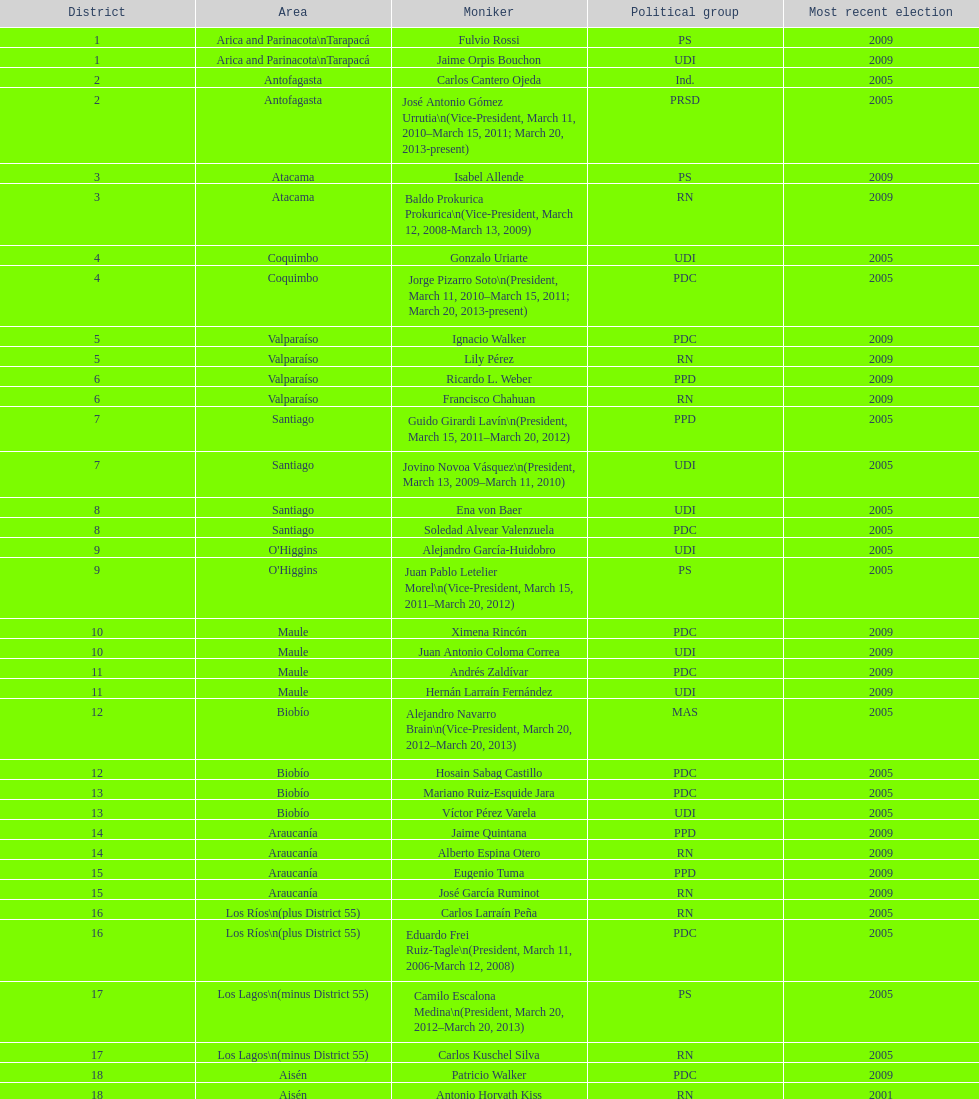How many total consituency are listed in the table? 19. Give me the full table as a dictionary. {'header': ['District', 'Area', 'Moniker', 'Political group', 'Most recent election'], 'rows': [['1', 'Arica and Parinacota\\nTarapacá', 'Fulvio Rossi', 'PS', '2009'], ['1', 'Arica and Parinacota\\nTarapacá', 'Jaime Orpis Bouchon', 'UDI', '2009'], ['2', 'Antofagasta', 'Carlos Cantero Ojeda', 'Ind.', '2005'], ['2', 'Antofagasta', 'José Antonio Gómez Urrutia\\n(Vice-President, March 11, 2010–March 15, 2011; March 20, 2013-present)', 'PRSD', '2005'], ['3', 'Atacama', 'Isabel Allende', 'PS', '2009'], ['3', 'Atacama', 'Baldo Prokurica Prokurica\\n(Vice-President, March 12, 2008-March 13, 2009)', 'RN', '2009'], ['4', 'Coquimbo', 'Gonzalo Uriarte', 'UDI', '2005'], ['4', 'Coquimbo', 'Jorge Pizarro Soto\\n(President, March 11, 2010–March 15, 2011; March 20, 2013-present)', 'PDC', '2005'], ['5', 'Valparaíso', 'Ignacio Walker', 'PDC', '2009'], ['5', 'Valparaíso', 'Lily Pérez', 'RN', '2009'], ['6', 'Valparaíso', 'Ricardo L. Weber', 'PPD', '2009'], ['6', 'Valparaíso', 'Francisco Chahuan', 'RN', '2009'], ['7', 'Santiago', 'Guido Girardi Lavín\\n(President, March 15, 2011–March 20, 2012)', 'PPD', '2005'], ['7', 'Santiago', 'Jovino Novoa Vásquez\\n(President, March 13, 2009–March 11, 2010)', 'UDI', '2005'], ['8', 'Santiago', 'Ena von Baer', 'UDI', '2005'], ['8', 'Santiago', 'Soledad Alvear Valenzuela', 'PDC', '2005'], ['9', "O'Higgins", 'Alejandro García-Huidobro', 'UDI', '2005'], ['9', "O'Higgins", 'Juan Pablo Letelier Morel\\n(Vice-President, March 15, 2011–March 20, 2012)', 'PS', '2005'], ['10', 'Maule', 'Ximena Rincón', 'PDC', '2009'], ['10', 'Maule', 'Juan Antonio Coloma Correa', 'UDI', '2009'], ['11', 'Maule', 'Andrés Zaldívar', 'PDC', '2009'], ['11', 'Maule', 'Hernán Larraín Fernández', 'UDI', '2009'], ['12', 'Biobío', 'Alejandro Navarro Brain\\n(Vice-President, March 20, 2012–March 20, 2013)', 'MAS', '2005'], ['12', 'Biobío', 'Hosain Sabag Castillo', 'PDC', '2005'], ['13', 'Biobío', 'Mariano Ruiz-Esquide Jara', 'PDC', '2005'], ['13', 'Biobío', 'Víctor Pérez Varela', 'UDI', '2005'], ['14', 'Araucanía', 'Jaime Quintana', 'PPD', '2009'], ['14', 'Araucanía', 'Alberto Espina Otero', 'RN', '2009'], ['15', 'Araucanía', 'Eugenio Tuma', 'PPD', '2009'], ['15', 'Araucanía', 'José García Ruminot', 'RN', '2009'], ['16', 'Los Ríos\\n(plus District 55)', 'Carlos Larraín Peña', 'RN', '2005'], ['16', 'Los Ríos\\n(plus District 55)', 'Eduardo Frei Ruiz-Tagle\\n(President, March 11, 2006-March 12, 2008)', 'PDC', '2005'], ['17', 'Los Lagos\\n(minus District 55)', 'Camilo Escalona Medina\\n(President, March 20, 2012–March 20, 2013)', 'PS', '2005'], ['17', 'Los Lagos\\n(minus District 55)', 'Carlos Kuschel Silva', 'RN', '2005'], ['18', 'Aisén', 'Patricio Walker', 'PDC', '2009'], ['18', 'Aisén', 'Antonio Horvath Kiss', 'RN', '2001'], ['19', 'Magallanes', 'Carlos Bianchi Chelech\\n(Vice-President, March 13, 2009–March 11, 2010)', 'Ind.', '2005'], ['19', 'Magallanes', 'Pedro Muñoz Aburto', 'PS', '2005']]} 